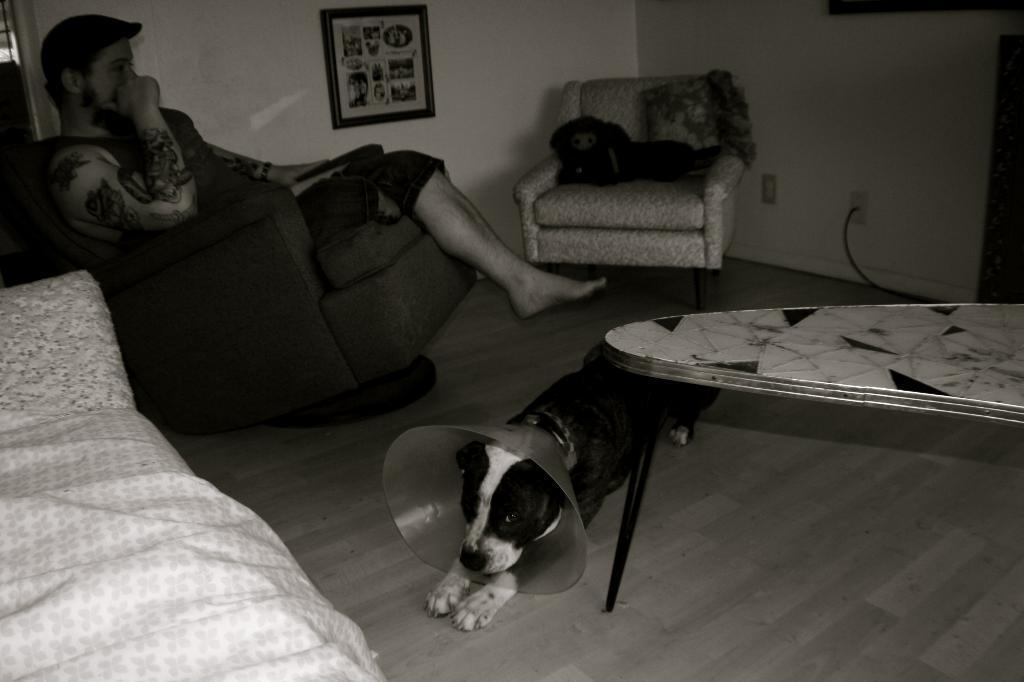Can you describe this image briefly? In this image i can see a man sitting on a couch, he is wearing a shirt and a jeans at left i can see a bed in white color, there is dog in front of a man sitting on the floor, at right there is a table in white color at the back ground i can see other couch in white color on the couch there's a doll there's frame attached to a white wall. 